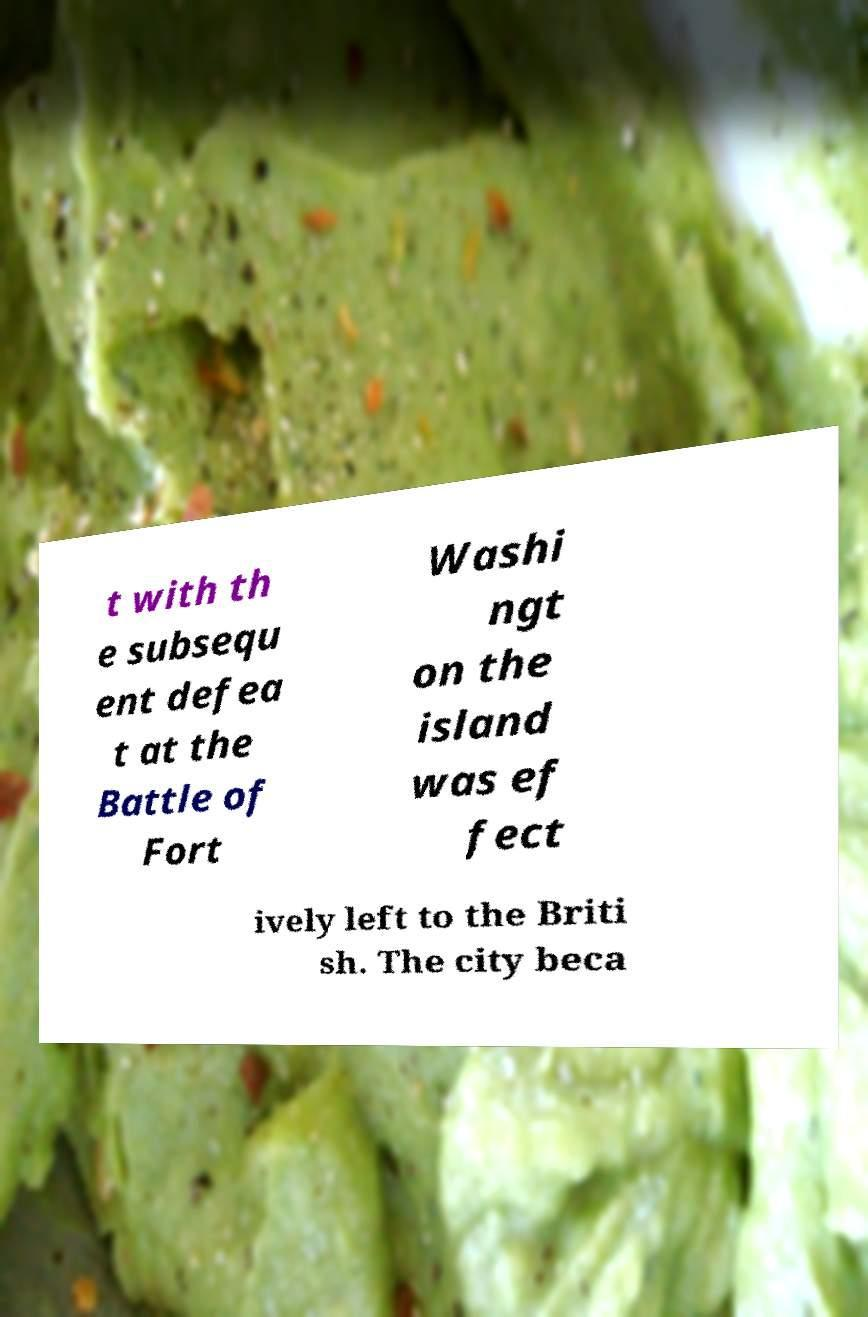What messages or text are displayed in this image? I need them in a readable, typed format. t with th e subsequ ent defea t at the Battle of Fort Washi ngt on the island was ef fect ively left to the Briti sh. The city beca 